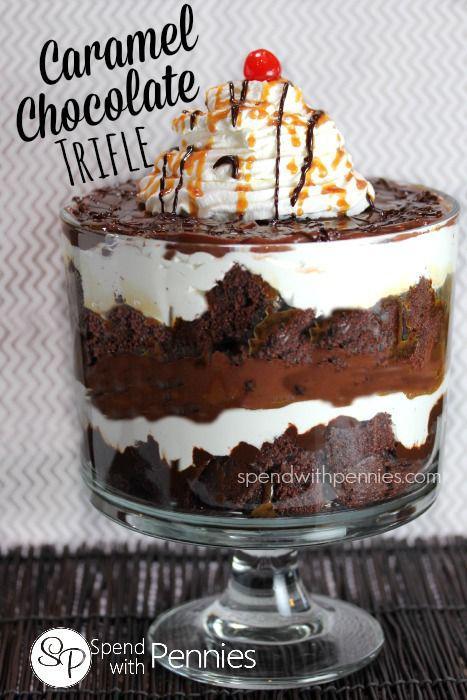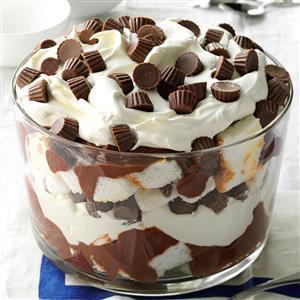The first image is the image on the left, the second image is the image on the right. Considering the images on both sides, is "Two large trifle desserts are made in clear bowls with chocolate and creamy layers, ending with garnished creamy topping." valid? Answer yes or no. Yes. 